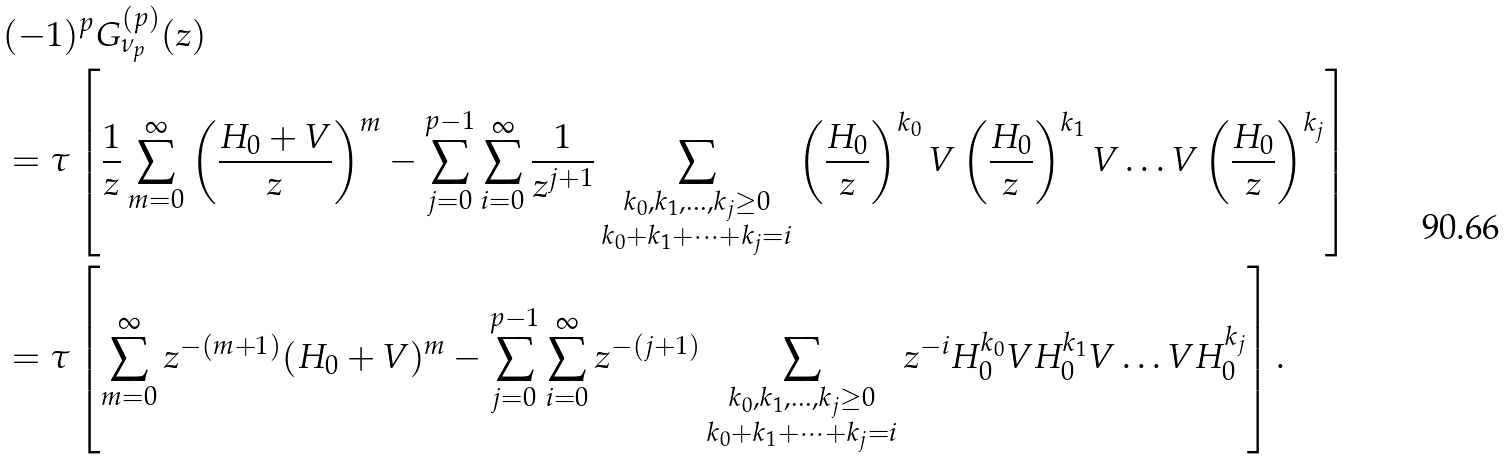<formula> <loc_0><loc_0><loc_500><loc_500>& ( - 1 ) ^ { p } G _ { \nu _ { p } } ^ { ( p ) } ( z ) \\ & = \tau \left [ \frac { 1 } { z } \sum _ { m = 0 } ^ { \infty } \left ( \frac { H _ { 0 } + V } { z } \right ) ^ { m } - \sum _ { j = 0 } ^ { p - 1 } \sum _ { i = 0 } ^ { \infty } \frac { 1 } { z ^ { j + 1 } } \sum _ { \substack { k _ { 0 } , k _ { 1 } , \dots , k _ { j } \geq 0 \\ k _ { 0 } + k _ { 1 } + \dots + k _ { j } = i } } \left ( \frac { H _ { 0 } } { z } \right ) ^ { k _ { 0 } } V \left ( \frac { H _ { 0 } } { z } \right ) ^ { k _ { 1 } } V \dots V \left ( \frac { H _ { 0 } } { z } \right ) ^ { k _ { j } } \right ] \\ & = \tau \left [ \sum _ { m = 0 } ^ { \infty } z ^ { - ( m + 1 ) } ( H _ { 0 } + V ) ^ { m } - \sum _ { j = 0 } ^ { p - 1 } \sum _ { i = 0 } ^ { \infty } z ^ { - ( j + 1 ) } \sum _ { \substack { k _ { 0 } , k _ { 1 } , \dots , k _ { j } \geq 0 \\ k _ { 0 } + k _ { 1 } + \dots + k _ { j } = i } } z ^ { - i } H _ { 0 } ^ { k _ { 0 } } V H _ { 0 } ^ { k _ { 1 } } V \dots V H _ { 0 } ^ { k _ { j } } \right ] .</formula> 